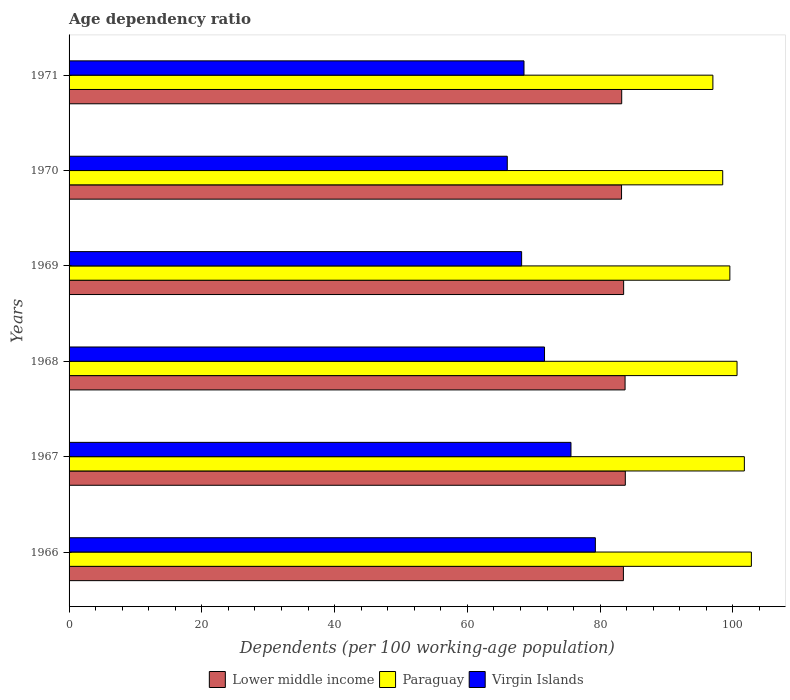How many different coloured bars are there?
Provide a succinct answer. 3. How many groups of bars are there?
Provide a succinct answer. 6. Are the number of bars on each tick of the Y-axis equal?
Offer a terse response. Yes. In how many cases, is the number of bars for a given year not equal to the number of legend labels?
Provide a succinct answer. 0. What is the age dependency ratio in in Lower middle income in 1971?
Your answer should be compact. 83.24. Across all years, what is the maximum age dependency ratio in in Lower middle income?
Keep it short and to the point. 83.79. Across all years, what is the minimum age dependency ratio in in Paraguay?
Offer a terse response. 96.98. In which year was the age dependency ratio in in Virgin Islands maximum?
Your answer should be compact. 1966. What is the total age dependency ratio in in Lower middle income in the graph?
Provide a short and direct response. 501.04. What is the difference between the age dependency ratio in in Virgin Islands in 1966 and that in 1968?
Give a very brief answer. 7.66. What is the difference between the age dependency ratio in in Lower middle income in 1971 and the age dependency ratio in in Paraguay in 1966?
Your response must be concise. -19.53. What is the average age dependency ratio in in Paraguay per year?
Offer a very short reply. 100.01. In the year 1971, what is the difference between the age dependency ratio in in Paraguay and age dependency ratio in in Lower middle income?
Provide a short and direct response. 13.74. What is the ratio of the age dependency ratio in in Paraguay in 1969 to that in 1970?
Offer a very short reply. 1.01. Is the age dependency ratio in in Lower middle income in 1967 less than that in 1969?
Your answer should be compact. No. Is the difference between the age dependency ratio in in Paraguay in 1969 and 1971 greater than the difference between the age dependency ratio in in Lower middle income in 1969 and 1971?
Offer a very short reply. Yes. What is the difference between the highest and the second highest age dependency ratio in in Lower middle income?
Offer a terse response. 0.04. What is the difference between the highest and the lowest age dependency ratio in in Lower middle income?
Ensure brevity in your answer.  0.57. What does the 3rd bar from the top in 1970 represents?
Give a very brief answer. Lower middle income. What does the 2nd bar from the bottom in 1966 represents?
Give a very brief answer. Paraguay. Are all the bars in the graph horizontal?
Your answer should be compact. Yes. How many years are there in the graph?
Your response must be concise. 6. Does the graph contain any zero values?
Provide a short and direct response. No. Where does the legend appear in the graph?
Provide a succinct answer. Bottom center. What is the title of the graph?
Your response must be concise. Age dependency ratio. What is the label or title of the X-axis?
Your response must be concise. Dependents (per 100 working-age population). What is the Dependents (per 100 working-age population) of Lower middle income in 1966?
Provide a succinct answer. 83.5. What is the Dependents (per 100 working-age population) of Paraguay in 1966?
Offer a very short reply. 102.78. What is the Dependents (per 100 working-age population) in Virgin Islands in 1966?
Offer a terse response. 79.28. What is the Dependents (per 100 working-age population) of Lower middle income in 1967?
Ensure brevity in your answer.  83.79. What is the Dependents (per 100 working-age population) in Paraguay in 1967?
Your answer should be compact. 101.72. What is the Dependents (per 100 working-age population) in Virgin Islands in 1967?
Give a very brief answer. 75.6. What is the Dependents (per 100 working-age population) in Lower middle income in 1968?
Keep it short and to the point. 83.75. What is the Dependents (per 100 working-age population) of Paraguay in 1968?
Your response must be concise. 100.62. What is the Dependents (per 100 working-age population) in Virgin Islands in 1968?
Provide a short and direct response. 71.62. What is the Dependents (per 100 working-age population) of Lower middle income in 1969?
Ensure brevity in your answer.  83.54. What is the Dependents (per 100 working-age population) of Paraguay in 1969?
Provide a short and direct response. 99.53. What is the Dependents (per 100 working-age population) in Virgin Islands in 1969?
Provide a succinct answer. 68.17. What is the Dependents (per 100 working-age population) in Lower middle income in 1970?
Keep it short and to the point. 83.22. What is the Dependents (per 100 working-age population) in Paraguay in 1970?
Offer a very short reply. 98.46. What is the Dependents (per 100 working-age population) in Virgin Islands in 1970?
Your answer should be compact. 66.01. What is the Dependents (per 100 working-age population) of Lower middle income in 1971?
Provide a short and direct response. 83.24. What is the Dependents (per 100 working-age population) in Paraguay in 1971?
Give a very brief answer. 96.98. What is the Dependents (per 100 working-age population) of Virgin Islands in 1971?
Offer a terse response. 68.53. Across all years, what is the maximum Dependents (per 100 working-age population) of Lower middle income?
Provide a short and direct response. 83.79. Across all years, what is the maximum Dependents (per 100 working-age population) in Paraguay?
Your answer should be compact. 102.78. Across all years, what is the maximum Dependents (per 100 working-age population) of Virgin Islands?
Your answer should be compact. 79.28. Across all years, what is the minimum Dependents (per 100 working-age population) of Lower middle income?
Provide a succinct answer. 83.22. Across all years, what is the minimum Dependents (per 100 working-age population) of Paraguay?
Make the answer very short. 96.98. Across all years, what is the minimum Dependents (per 100 working-age population) of Virgin Islands?
Give a very brief answer. 66.01. What is the total Dependents (per 100 working-age population) of Lower middle income in the graph?
Your answer should be very brief. 501.04. What is the total Dependents (per 100 working-age population) in Paraguay in the graph?
Provide a short and direct response. 600.09. What is the total Dependents (per 100 working-age population) of Virgin Islands in the graph?
Offer a terse response. 429.2. What is the difference between the Dependents (per 100 working-age population) in Lower middle income in 1966 and that in 1967?
Provide a succinct answer. -0.29. What is the difference between the Dependents (per 100 working-age population) of Paraguay in 1966 and that in 1967?
Provide a short and direct response. 1.06. What is the difference between the Dependents (per 100 working-age population) in Virgin Islands in 1966 and that in 1967?
Ensure brevity in your answer.  3.67. What is the difference between the Dependents (per 100 working-age population) in Lower middle income in 1966 and that in 1968?
Give a very brief answer. -0.25. What is the difference between the Dependents (per 100 working-age population) of Paraguay in 1966 and that in 1968?
Your answer should be very brief. 2.16. What is the difference between the Dependents (per 100 working-age population) in Virgin Islands in 1966 and that in 1968?
Provide a short and direct response. 7.66. What is the difference between the Dependents (per 100 working-age population) in Lower middle income in 1966 and that in 1969?
Provide a succinct answer. -0.04. What is the difference between the Dependents (per 100 working-age population) of Paraguay in 1966 and that in 1969?
Ensure brevity in your answer.  3.24. What is the difference between the Dependents (per 100 working-age population) of Virgin Islands in 1966 and that in 1969?
Offer a very short reply. 11.11. What is the difference between the Dependents (per 100 working-age population) in Lower middle income in 1966 and that in 1970?
Your response must be concise. 0.28. What is the difference between the Dependents (per 100 working-age population) in Paraguay in 1966 and that in 1970?
Give a very brief answer. 4.32. What is the difference between the Dependents (per 100 working-age population) of Virgin Islands in 1966 and that in 1970?
Your answer should be very brief. 13.27. What is the difference between the Dependents (per 100 working-age population) of Lower middle income in 1966 and that in 1971?
Your answer should be compact. 0.26. What is the difference between the Dependents (per 100 working-age population) in Paraguay in 1966 and that in 1971?
Provide a short and direct response. 5.8. What is the difference between the Dependents (per 100 working-age population) of Virgin Islands in 1966 and that in 1971?
Offer a very short reply. 10.75. What is the difference between the Dependents (per 100 working-age population) of Lower middle income in 1967 and that in 1968?
Your answer should be compact. 0.04. What is the difference between the Dependents (per 100 working-age population) in Paraguay in 1967 and that in 1968?
Keep it short and to the point. 1.1. What is the difference between the Dependents (per 100 working-age population) in Virgin Islands in 1967 and that in 1968?
Offer a terse response. 3.99. What is the difference between the Dependents (per 100 working-age population) in Lower middle income in 1967 and that in 1969?
Offer a very short reply. 0.25. What is the difference between the Dependents (per 100 working-age population) of Paraguay in 1967 and that in 1969?
Provide a succinct answer. 2.19. What is the difference between the Dependents (per 100 working-age population) in Virgin Islands in 1967 and that in 1969?
Make the answer very short. 7.43. What is the difference between the Dependents (per 100 working-age population) in Lower middle income in 1967 and that in 1970?
Your response must be concise. 0.57. What is the difference between the Dependents (per 100 working-age population) of Paraguay in 1967 and that in 1970?
Ensure brevity in your answer.  3.26. What is the difference between the Dependents (per 100 working-age population) in Virgin Islands in 1967 and that in 1970?
Keep it short and to the point. 9.59. What is the difference between the Dependents (per 100 working-age population) of Lower middle income in 1967 and that in 1971?
Keep it short and to the point. 0.55. What is the difference between the Dependents (per 100 working-age population) in Paraguay in 1967 and that in 1971?
Provide a succinct answer. 4.74. What is the difference between the Dependents (per 100 working-age population) of Virgin Islands in 1967 and that in 1971?
Give a very brief answer. 7.08. What is the difference between the Dependents (per 100 working-age population) of Lower middle income in 1968 and that in 1969?
Make the answer very short. 0.22. What is the difference between the Dependents (per 100 working-age population) in Paraguay in 1968 and that in 1969?
Offer a terse response. 1.08. What is the difference between the Dependents (per 100 working-age population) in Virgin Islands in 1968 and that in 1969?
Your answer should be very brief. 3.45. What is the difference between the Dependents (per 100 working-age population) of Lower middle income in 1968 and that in 1970?
Provide a short and direct response. 0.53. What is the difference between the Dependents (per 100 working-age population) in Paraguay in 1968 and that in 1970?
Give a very brief answer. 2.16. What is the difference between the Dependents (per 100 working-age population) in Virgin Islands in 1968 and that in 1970?
Offer a very short reply. 5.61. What is the difference between the Dependents (per 100 working-age population) of Lower middle income in 1968 and that in 1971?
Ensure brevity in your answer.  0.51. What is the difference between the Dependents (per 100 working-age population) in Paraguay in 1968 and that in 1971?
Ensure brevity in your answer.  3.64. What is the difference between the Dependents (per 100 working-age population) in Virgin Islands in 1968 and that in 1971?
Keep it short and to the point. 3.09. What is the difference between the Dependents (per 100 working-age population) in Lower middle income in 1969 and that in 1970?
Provide a short and direct response. 0.32. What is the difference between the Dependents (per 100 working-age population) in Paraguay in 1969 and that in 1970?
Provide a succinct answer. 1.07. What is the difference between the Dependents (per 100 working-age population) of Virgin Islands in 1969 and that in 1970?
Make the answer very short. 2.16. What is the difference between the Dependents (per 100 working-age population) of Lower middle income in 1969 and that in 1971?
Provide a short and direct response. 0.29. What is the difference between the Dependents (per 100 working-age population) in Paraguay in 1969 and that in 1971?
Provide a succinct answer. 2.56. What is the difference between the Dependents (per 100 working-age population) of Virgin Islands in 1969 and that in 1971?
Offer a terse response. -0.36. What is the difference between the Dependents (per 100 working-age population) in Lower middle income in 1970 and that in 1971?
Ensure brevity in your answer.  -0.02. What is the difference between the Dependents (per 100 working-age population) of Paraguay in 1970 and that in 1971?
Your response must be concise. 1.48. What is the difference between the Dependents (per 100 working-age population) in Virgin Islands in 1970 and that in 1971?
Your answer should be compact. -2.52. What is the difference between the Dependents (per 100 working-age population) in Lower middle income in 1966 and the Dependents (per 100 working-age population) in Paraguay in 1967?
Make the answer very short. -18.22. What is the difference between the Dependents (per 100 working-age population) in Lower middle income in 1966 and the Dependents (per 100 working-age population) in Virgin Islands in 1967?
Provide a succinct answer. 7.9. What is the difference between the Dependents (per 100 working-age population) in Paraguay in 1966 and the Dependents (per 100 working-age population) in Virgin Islands in 1967?
Make the answer very short. 27.17. What is the difference between the Dependents (per 100 working-age population) of Lower middle income in 1966 and the Dependents (per 100 working-age population) of Paraguay in 1968?
Make the answer very short. -17.12. What is the difference between the Dependents (per 100 working-age population) in Lower middle income in 1966 and the Dependents (per 100 working-age population) in Virgin Islands in 1968?
Your answer should be compact. 11.88. What is the difference between the Dependents (per 100 working-age population) in Paraguay in 1966 and the Dependents (per 100 working-age population) in Virgin Islands in 1968?
Ensure brevity in your answer.  31.16. What is the difference between the Dependents (per 100 working-age population) of Lower middle income in 1966 and the Dependents (per 100 working-age population) of Paraguay in 1969?
Make the answer very short. -16.03. What is the difference between the Dependents (per 100 working-age population) of Lower middle income in 1966 and the Dependents (per 100 working-age population) of Virgin Islands in 1969?
Keep it short and to the point. 15.33. What is the difference between the Dependents (per 100 working-age population) of Paraguay in 1966 and the Dependents (per 100 working-age population) of Virgin Islands in 1969?
Provide a succinct answer. 34.61. What is the difference between the Dependents (per 100 working-age population) in Lower middle income in 1966 and the Dependents (per 100 working-age population) in Paraguay in 1970?
Offer a very short reply. -14.96. What is the difference between the Dependents (per 100 working-age population) of Lower middle income in 1966 and the Dependents (per 100 working-age population) of Virgin Islands in 1970?
Your response must be concise. 17.49. What is the difference between the Dependents (per 100 working-age population) of Paraguay in 1966 and the Dependents (per 100 working-age population) of Virgin Islands in 1970?
Your answer should be compact. 36.77. What is the difference between the Dependents (per 100 working-age population) of Lower middle income in 1966 and the Dependents (per 100 working-age population) of Paraguay in 1971?
Provide a succinct answer. -13.48. What is the difference between the Dependents (per 100 working-age population) of Lower middle income in 1966 and the Dependents (per 100 working-age population) of Virgin Islands in 1971?
Offer a very short reply. 14.97. What is the difference between the Dependents (per 100 working-age population) in Paraguay in 1966 and the Dependents (per 100 working-age population) in Virgin Islands in 1971?
Offer a terse response. 34.25. What is the difference between the Dependents (per 100 working-age population) in Lower middle income in 1967 and the Dependents (per 100 working-age population) in Paraguay in 1968?
Keep it short and to the point. -16.83. What is the difference between the Dependents (per 100 working-age population) of Lower middle income in 1967 and the Dependents (per 100 working-age population) of Virgin Islands in 1968?
Keep it short and to the point. 12.17. What is the difference between the Dependents (per 100 working-age population) in Paraguay in 1967 and the Dependents (per 100 working-age population) in Virgin Islands in 1968?
Keep it short and to the point. 30.1. What is the difference between the Dependents (per 100 working-age population) of Lower middle income in 1967 and the Dependents (per 100 working-age population) of Paraguay in 1969?
Your answer should be very brief. -15.75. What is the difference between the Dependents (per 100 working-age population) of Lower middle income in 1967 and the Dependents (per 100 working-age population) of Virgin Islands in 1969?
Your answer should be very brief. 15.62. What is the difference between the Dependents (per 100 working-age population) of Paraguay in 1967 and the Dependents (per 100 working-age population) of Virgin Islands in 1969?
Offer a terse response. 33.55. What is the difference between the Dependents (per 100 working-age population) in Lower middle income in 1967 and the Dependents (per 100 working-age population) in Paraguay in 1970?
Make the answer very short. -14.67. What is the difference between the Dependents (per 100 working-age population) in Lower middle income in 1967 and the Dependents (per 100 working-age population) in Virgin Islands in 1970?
Offer a very short reply. 17.78. What is the difference between the Dependents (per 100 working-age population) in Paraguay in 1967 and the Dependents (per 100 working-age population) in Virgin Islands in 1970?
Ensure brevity in your answer.  35.71. What is the difference between the Dependents (per 100 working-age population) of Lower middle income in 1967 and the Dependents (per 100 working-age population) of Paraguay in 1971?
Ensure brevity in your answer.  -13.19. What is the difference between the Dependents (per 100 working-age population) of Lower middle income in 1967 and the Dependents (per 100 working-age population) of Virgin Islands in 1971?
Keep it short and to the point. 15.26. What is the difference between the Dependents (per 100 working-age population) in Paraguay in 1967 and the Dependents (per 100 working-age population) in Virgin Islands in 1971?
Keep it short and to the point. 33.19. What is the difference between the Dependents (per 100 working-age population) of Lower middle income in 1968 and the Dependents (per 100 working-age population) of Paraguay in 1969?
Provide a succinct answer. -15.78. What is the difference between the Dependents (per 100 working-age population) of Lower middle income in 1968 and the Dependents (per 100 working-age population) of Virgin Islands in 1969?
Your answer should be compact. 15.58. What is the difference between the Dependents (per 100 working-age population) in Paraguay in 1968 and the Dependents (per 100 working-age population) in Virgin Islands in 1969?
Offer a very short reply. 32.45. What is the difference between the Dependents (per 100 working-age population) of Lower middle income in 1968 and the Dependents (per 100 working-age population) of Paraguay in 1970?
Offer a terse response. -14.71. What is the difference between the Dependents (per 100 working-age population) of Lower middle income in 1968 and the Dependents (per 100 working-age population) of Virgin Islands in 1970?
Keep it short and to the point. 17.74. What is the difference between the Dependents (per 100 working-age population) of Paraguay in 1968 and the Dependents (per 100 working-age population) of Virgin Islands in 1970?
Your response must be concise. 34.61. What is the difference between the Dependents (per 100 working-age population) in Lower middle income in 1968 and the Dependents (per 100 working-age population) in Paraguay in 1971?
Provide a short and direct response. -13.23. What is the difference between the Dependents (per 100 working-age population) of Lower middle income in 1968 and the Dependents (per 100 working-age population) of Virgin Islands in 1971?
Provide a succinct answer. 15.23. What is the difference between the Dependents (per 100 working-age population) in Paraguay in 1968 and the Dependents (per 100 working-age population) in Virgin Islands in 1971?
Make the answer very short. 32.09. What is the difference between the Dependents (per 100 working-age population) in Lower middle income in 1969 and the Dependents (per 100 working-age population) in Paraguay in 1970?
Make the answer very short. -14.92. What is the difference between the Dependents (per 100 working-age population) of Lower middle income in 1969 and the Dependents (per 100 working-age population) of Virgin Islands in 1970?
Keep it short and to the point. 17.53. What is the difference between the Dependents (per 100 working-age population) of Paraguay in 1969 and the Dependents (per 100 working-age population) of Virgin Islands in 1970?
Give a very brief answer. 33.53. What is the difference between the Dependents (per 100 working-age population) in Lower middle income in 1969 and the Dependents (per 100 working-age population) in Paraguay in 1971?
Ensure brevity in your answer.  -13.44. What is the difference between the Dependents (per 100 working-age population) of Lower middle income in 1969 and the Dependents (per 100 working-age population) of Virgin Islands in 1971?
Offer a very short reply. 15.01. What is the difference between the Dependents (per 100 working-age population) in Paraguay in 1969 and the Dependents (per 100 working-age population) in Virgin Islands in 1971?
Your answer should be compact. 31.01. What is the difference between the Dependents (per 100 working-age population) of Lower middle income in 1970 and the Dependents (per 100 working-age population) of Paraguay in 1971?
Provide a short and direct response. -13.76. What is the difference between the Dependents (per 100 working-age population) of Lower middle income in 1970 and the Dependents (per 100 working-age population) of Virgin Islands in 1971?
Provide a short and direct response. 14.69. What is the difference between the Dependents (per 100 working-age population) in Paraguay in 1970 and the Dependents (per 100 working-age population) in Virgin Islands in 1971?
Your answer should be very brief. 29.93. What is the average Dependents (per 100 working-age population) of Lower middle income per year?
Provide a succinct answer. 83.51. What is the average Dependents (per 100 working-age population) of Paraguay per year?
Your response must be concise. 100.01. What is the average Dependents (per 100 working-age population) of Virgin Islands per year?
Provide a short and direct response. 71.53. In the year 1966, what is the difference between the Dependents (per 100 working-age population) in Lower middle income and Dependents (per 100 working-age population) in Paraguay?
Give a very brief answer. -19.28. In the year 1966, what is the difference between the Dependents (per 100 working-age population) of Lower middle income and Dependents (per 100 working-age population) of Virgin Islands?
Your answer should be compact. 4.23. In the year 1966, what is the difference between the Dependents (per 100 working-age population) in Paraguay and Dependents (per 100 working-age population) in Virgin Islands?
Make the answer very short. 23.5. In the year 1967, what is the difference between the Dependents (per 100 working-age population) in Lower middle income and Dependents (per 100 working-age population) in Paraguay?
Make the answer very short. -17.93. In the year 1967, what is the difference between the Dependents (per 100 working-age population) in Lower middle income and Dependents (per 100 working-age population) in Virgin Islands?
Your response must be concise. 8.19. In the year 1967, what is the difference between the Dependents (per 100 working-age population) in Paraguay and Dependents (per 100 working-age population) in Virgin Islands?
Ensure brevity in your answer.  26.12. In the year 1968, what is the difference between the Dependents (per 100 working-age population) of Lower middle income and Dependents (per 100 working-age population) of Paraguay?
Your answer should be very brief. -16.86. In the year 1968, what is the difference between the Dependents (per 100 working-age population) of Lower middle income and Dependents (per 100 working-age population) of Virgin Islands?
Offer a terse response. 12.13. In the year 1968, what is the difference between the Dependents (per 100 working-age population) in Paraguay and Dependents (per 100 working-age population) in Virgin Islands?
Provide a short and direct response. 29. In the year 1969, what is the difference between the Dependents (per 100 working-age population) of Lower middle income and Dependents (per 100 working-age population) of Paraguay?
Give a very brief answer. -16. In the year 1969, what is the difference between the Dependents (per 100 working-age population) of Lower middle income and Dependents (per 100 working-age population) of Virgin Islands?
Ensure brevity in your answer.  15.37. In the year 1969, what is the difference between the Dependents (per 100 working-age population) in Paraguay and Dependents (per 100 working-age population) in Virgin Islands?
Keep it short and to the point. 31.37. In the year 1970, what is the difference between the Dependents (per 100 working-age population) in Lower middle income and Dependents (per 100 working-age population) in Paraguay?
Keep it short and to the point. -15.24. In the year 1970, what is the difference between the Dependents (per 100 working-age population) of Lower middle income and Dependents (per 100 working-age population) of Virgin Islands?
Your response must be concise. 17.21. In the year 1970, what is the difference between the Dependents (per 100 working-age population) of Paraguay and Dependents (per 100 working-age population) of Virgin Islands?
Ensure brevity in your answer.  32.45. In the year 1971, what is the difference between the Dependents (per 100 working-age population) of Lower middle income and Dependents (per 100 working-age population) of Paraguay?
Make the answer very short. -13.74. In the year 1971, what is the difference between the Dependents (per 100 working-age population) in Lower middle income and Dependents (per 100 working-age population) in Virgin Islands?
Give a very brief answer. 14.72. In the year 1971, what is the difference between the Dependents (per 100 working-age population) in Paraguay and Dependents (per 100 working-age population) in Virgin Islands?
Ensure brevity in your answer.  28.45. What is the ratio of the Dependents (per 100 working-age population) in Lower middle income in 1966 to that in 1967?
Your answer should be compact. 1. What is the ratio of the Dependents (per 100 working-age population) in Paraguay in 1966 to that in 1967?
Your response must be concise. 1.01. What is the ratio of the Dependents (per 100 working-age population) in Virgin Islands in 1966 to that in 1967?
Provide a succinct answer. 1.05. What is the ratio of the Dependents (per 100 working-age population) of Paraguay in 1966 to that in 1968?
Give a very brief answer. 1.02. What is the ratio of the Dependents (per 100 working-age population) in Virgin Islands in 1966 to that in 1968?
Ensure brevity in your answer.  1.11. What is the ratio of the Dependents (per 100 working-age population) of Lower middle income in 1966 to that in 1969?
Give a very brief answer. 1. What is the ratio of the Dependents (per 100 working-age population) of Paraguay in 1966 to that in 1969?
Offer a terse response. 1.03. What is the ratio of the Dependents (per 100 working-age population) of Virgin Islands in 1966 to that in 1969?
Offer a terse response. 1.16. What is the ratio of the Dependents (per 100 working-age population) in Paraguay in 1966 to that in 1970?
Your response must be concise. 1.04. What is the ratio of the Dependents (per 100 working-age population) of Virgin Islands in 1966 to that in 1970?
Give a very brief answer. 1.2. What is the ratio of the Dependents (per 100 working-age population) in Lower middle income in 1966 to that in 1971?
Keep it short and to the point. 1. What is the ratio of the Dependents (per 100 working-age population) in Paraguay in 1966 to that in 1971?
Keep it short and to the point. 1.06. What is the ratio of the Dependents (per 100 working-age population) of Virgin Islands in 1966 to that in 1971?
Provide a short and direct response. 1.16. What is the ratio of the Dependents (per 100 working-age population) of Virgin Islands in 1967 to that in 1968?
Make the answer very short. 1.06. What is the ratio of the Dependents (per 100 working-age population) of Lower middle income in 1967 to that in 1969?
Your answer should be compact. 1. What is the ratio of the Dependents (per 100 working-age population) in Virgin Islands in 1967 to that in 1969?
Your answer should be very brief. 1.11. What is the ratio of the Dependents (per 100 working-age population) in Lower middle income in 1967 to that in 1970?
Offer a terse response. 1.01. What is the ratio of the Dependents (per 100 working-age population) of Paraguay in 1967 to that in 1970?
Provide a succinct answer. 1.03. What is the ratio of the Dependents (per 100 working-age population) of Virgin Islands in 1967 to that in 1970?
Your response must be concise. 1.15. What is the ratio of the Dependents (per 100 working-age population) of Paraguay in 1967 to that in 1971?
Your answer should be very brief. 1.05. What is the ratio of the Dependents (per 100 working-age population) of Virgin Islands in 1967 to that in 1971?
Provide a short and direct response. 1.1. What is the ratio of the Dependents (per 100 working-age population) of Paraguay in 1968 to that in 1969?
Provide a succinct answer. 1.01. What is the ratio of the Dependents (per 100 working-age population) in Virgin Islands in 1968 to that in 1969?
Ensure brevity in your answer.  1.05. What is the ratio of the Dependents (per 100 working-age population) in Lower middle income in 1968 to that in 1970?
Your response must be concise. 1.01. What is the ratio of the Dependents (per 100 working-age population) in Paraguay in 1968 to that in 1970?
Provide a short and direct response. 1.02. What is the ratio of the Dependents (per 100 working-age population) in Virgin Islands in 1968 to that in 1970?
Provide a short and direct response. 1.08. What is the ratio of the Dependents (per 100 working-age population) of Lower middle income in 1968 to that in 1971?
Your answer should be very brief. 1.01. What is the ratio of the Dependents (per 100 working-age population) of Paraguay in 1968 to that in 1971?
Your answer should be compact. 1.04. What is the ratio of the Dependents (per 100 working-age population) in Virgin Islands in 1968 to that in 1971?
Your answer should be very brief. 1.05. What is the ratio of the Dependents (per 100 working-age population) in Lower middle income in 1969 to that in 1970?
Provide a succinct answer. 1. What is the ratio of the Dependents (per 100 working-age population) in Paraguay in 1969 to that in 1970?
Make the answer very short. 1.01. What is the ratio of the Dependents (per 100 working-age population) in Virgin Islands in 1969 to that in 1970?
Give a very brief answer. 1.03. What is the ratio of the Dependents (per 100 working-age population) of Lower middle income in 1969 to that in 1971?
Provide a short and direct response. 1. What is the ratio of the Dependents (per 100 working-age population) in Paraguay in 1969 to that in 1971?
Provide a short and direct response. 1.03. What is the ratio of the Dependents (per 100 working-age population) in Virgin Islands in 1969 to that in 1971?
Your response must be concise. 0.99. What is the ratio of the Dependents (per 100 working-age population) in Paraguay in 1970 to that in 1971?
Make the answer very short. 1.02. What is the ratio of the Dependents (per 100 working-age population) in Virgin Islands in 1970 to that in 1971?
Make the answer very short. 0.96. What is the difference between the highest and the second highest Dependents (per 100 working-age population) in Lower middle income?
Keep it short and to the point. 0.04. What is the difference between the highest and the second highest Dependents (per 100 working-age population) of Paraguay?
Your response must be concise. 1.06. What is the difference between the highest and the second highest Dependents (per 100 working-age population) in Virgin Islands?
Offer a terse response. 3.67. What is the difference between the highest and the lowest Dependents (per 100 working-age population) of Lower middle income?
Your response must be concise. 0.57. What is the difference between the highest and the lowest Dependents (per 100 working-age population) in Paraguay?
Keep it short and to the point. 5.8. What is the difference between the highest and the lowest Dependents (per 100 working-age population) of Virgin Islands?
Your answer should be compact. 13.27. 